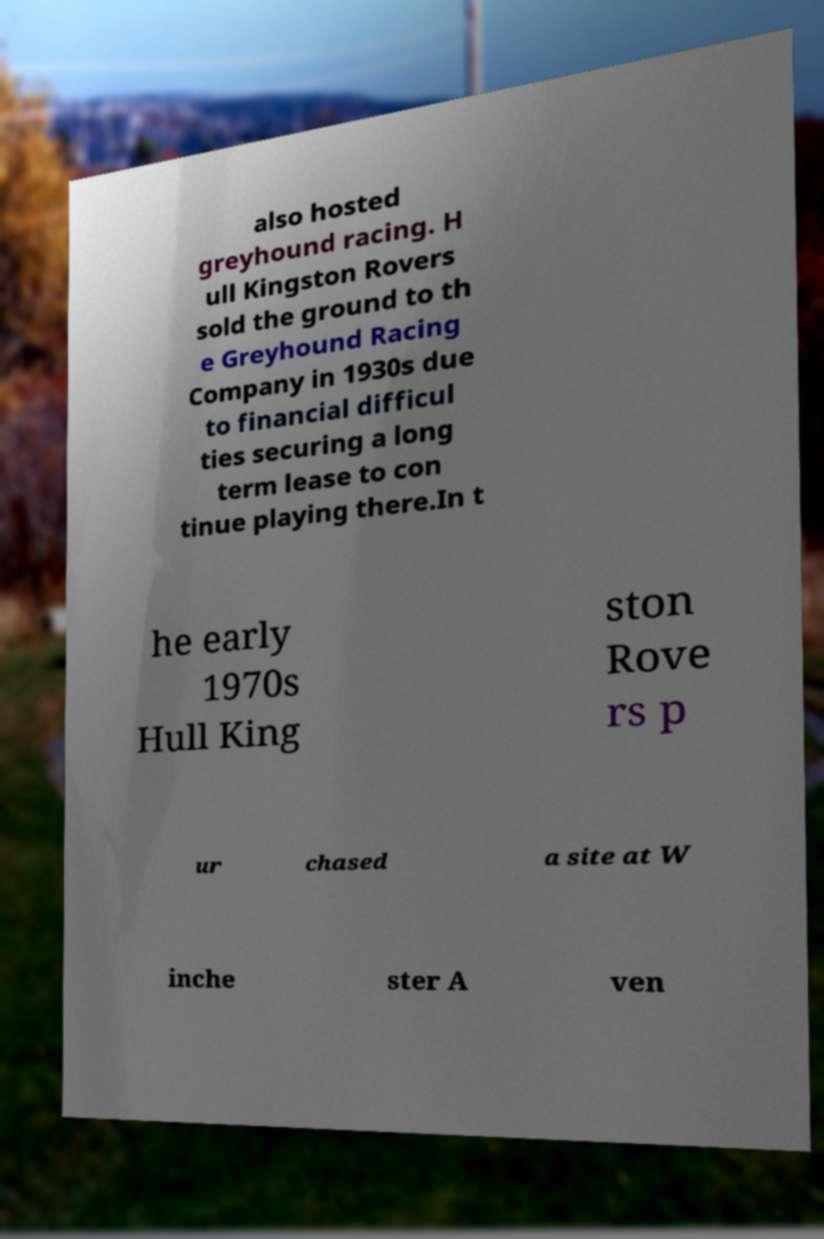Could you assist in decoding the text presented in this image and type it out clearly? also hosted greyhound racing. H ull Kingston Rovers sold the ground to th e Greyhound Racing Company in 1930s due to financial difficul ties securing a long term lease to con tinue playing there.In t he early 1970s Hull King ston Rove rs p ur chased a site at W inche ster A ven 